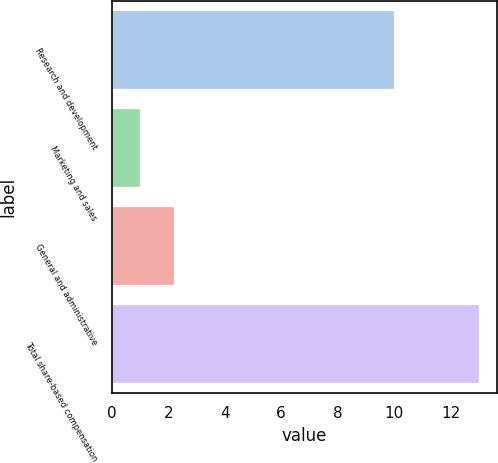Convert chart to OTSL. <chart><loc_0><loc_0><loc_500><loc_500><bar_chart><fcel>Research and development<fcel>Marketing and sales<fcel>General and administrative<fcel>Total share-based compensation<nl><fcel>10<fcel>1<fcel>2.2<fcel>13<nl></chart> 